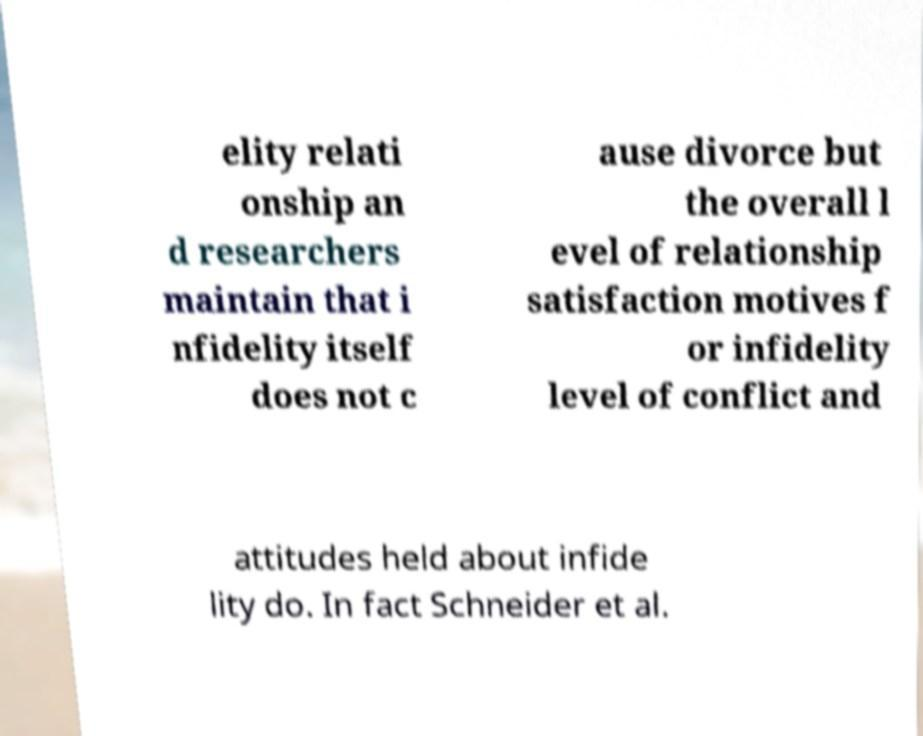Can you read and provide the text displayed in the image?This photo seems to have some interesting text. Can you extract and type it out for me? elity relati onship an d researchers maintain that i nfidelity itself does not c ause divorce but the overall l evel of relationship satisfaction motives f or infidelity level of conflict and attitudes held about infide lity do. In fact Schneider et al. 